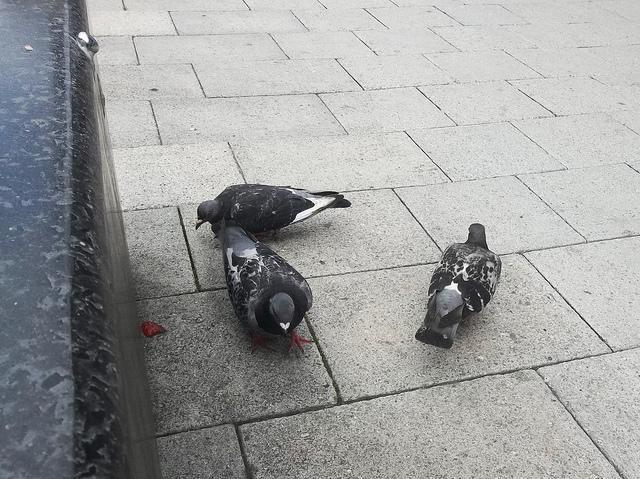How many birds are in the photo?
Give a very brief answer. 3. 